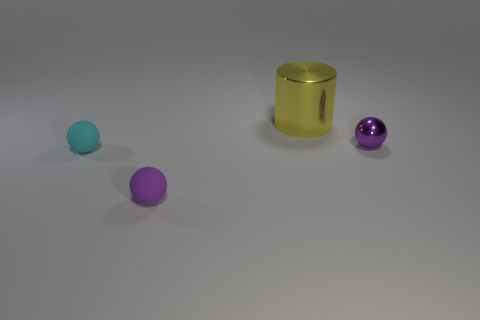Is the number of small cyan matte balls less than the number of tiny red things?
Offer a terse response. No. What shape is the big object?
Your answer should be very brief. Cylinder. Is the color of the small rubber thing in front of the cyan object the same as the metal cylinder?
Provide a succinct answer. No. What is the shape of the tiny object that is to the left of the metal ball and behind the tiny purple rubber object?
Provide a short and direct response. Sphere. The shiny thing behind the tiny purple shiny ball is what color?
Ensure brevity in your answer.  Yellow. Are there any other things of the same color as the cylinder?
Provide a short and direct response. No. Do the cyan rubber thing and the yellow thing have the same size?
Offer a terse response. No. What is the size of the sphere that is on the right side of the tiny cyan matte object and behind the small purple rubber ball?
Your answer should be compact. Small. How many tiny cylinders have the same material as the cyan sphere?
Your answer should be very brief. 0. The big thing has what color?
Keep it short and to the point. Yellow. 